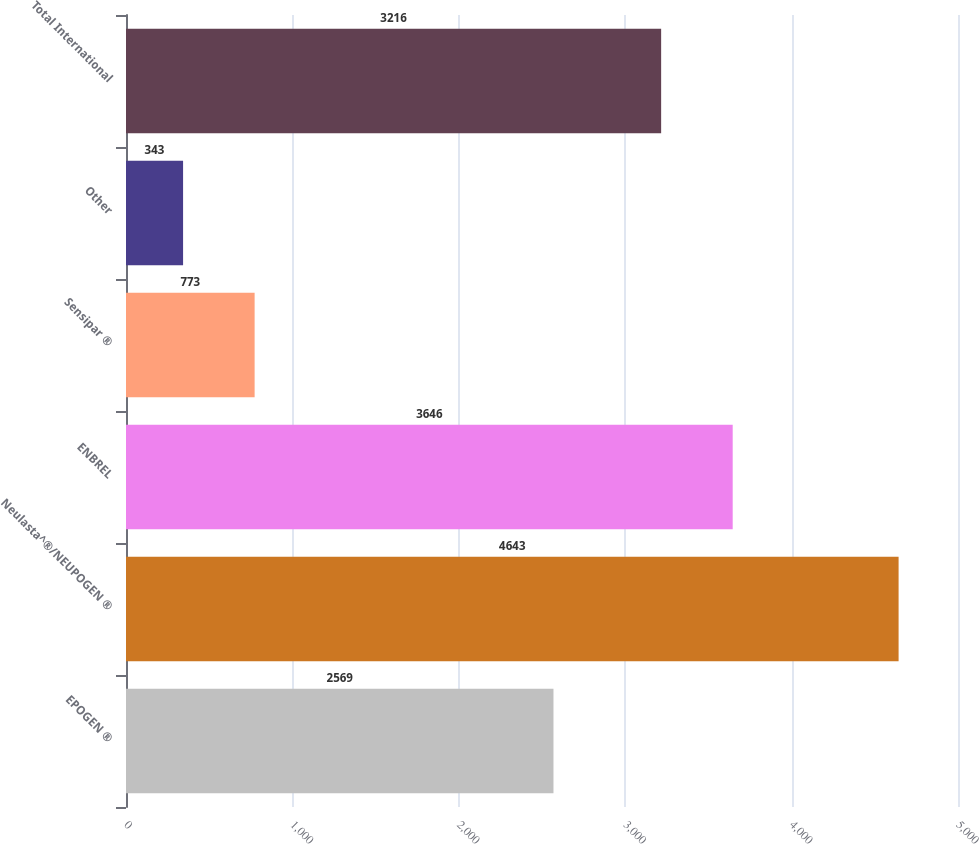Convert chart. <chart><loc_0><loc_0><loc_500><loc_500><bar_chart><fcel>EPOGEN ®<fcel>Neulasta^®/NEUPOGEN ®<fcel>ENBREL<fcel>Sensipar ®<fcel>Other<fcel>Total International<nl><fcel>2569<fcel>4643<fcel>3646<fcel>773<fcel>343<fcel>3216<nl></chart> 